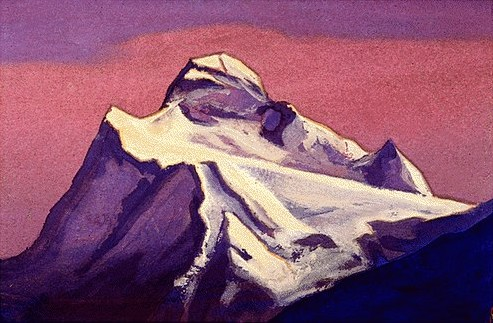What emotions does the painting evoke, and how does the artist achieve this effect? The painting evokes feelings of tranquility and awe, achieved through both the subject matter and the technique. The majestic, isolated peak, standing resiliently amid a sea of purple hues, taps into our sense of wonder towards nature. The loose, expressive brushwork typical of Impressionism enhances this effect by allowing the viewer's eye to meld colors from a distance, making the scene feel more dynamic and alive. 